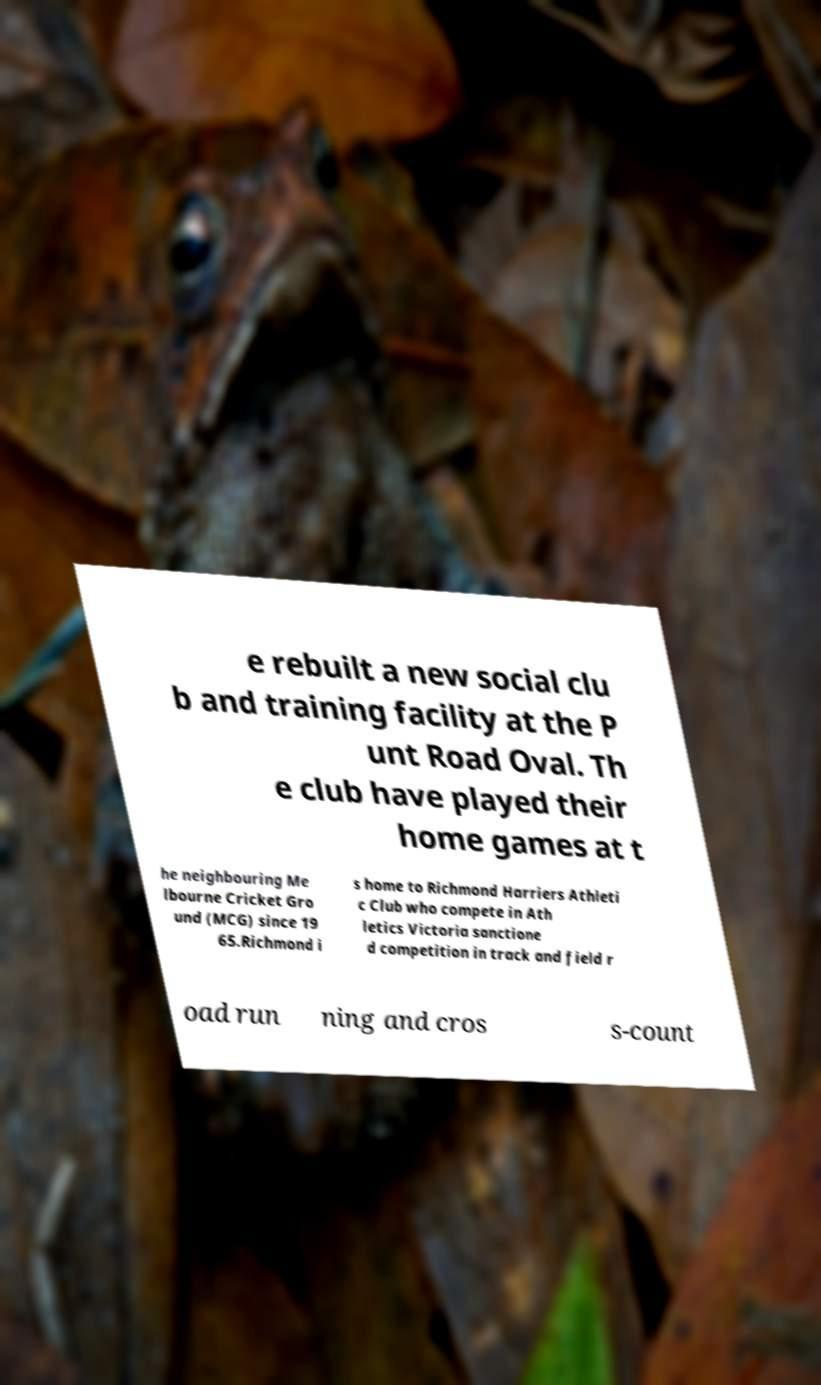I need the written content from this picture converted into text. Can you do that? e rebuilt a new social clu b and training facility at the P unt Road Oval. Th e club have played their home games at t he neighbouring Me lbourne Cricket Gro und (MCG) since 19 65.Richmond i s home to Richmond Harriers Athleti c Club who compete in Ath letics Victoria sanctione d competition in track and field r oad run ning and cros s-count 